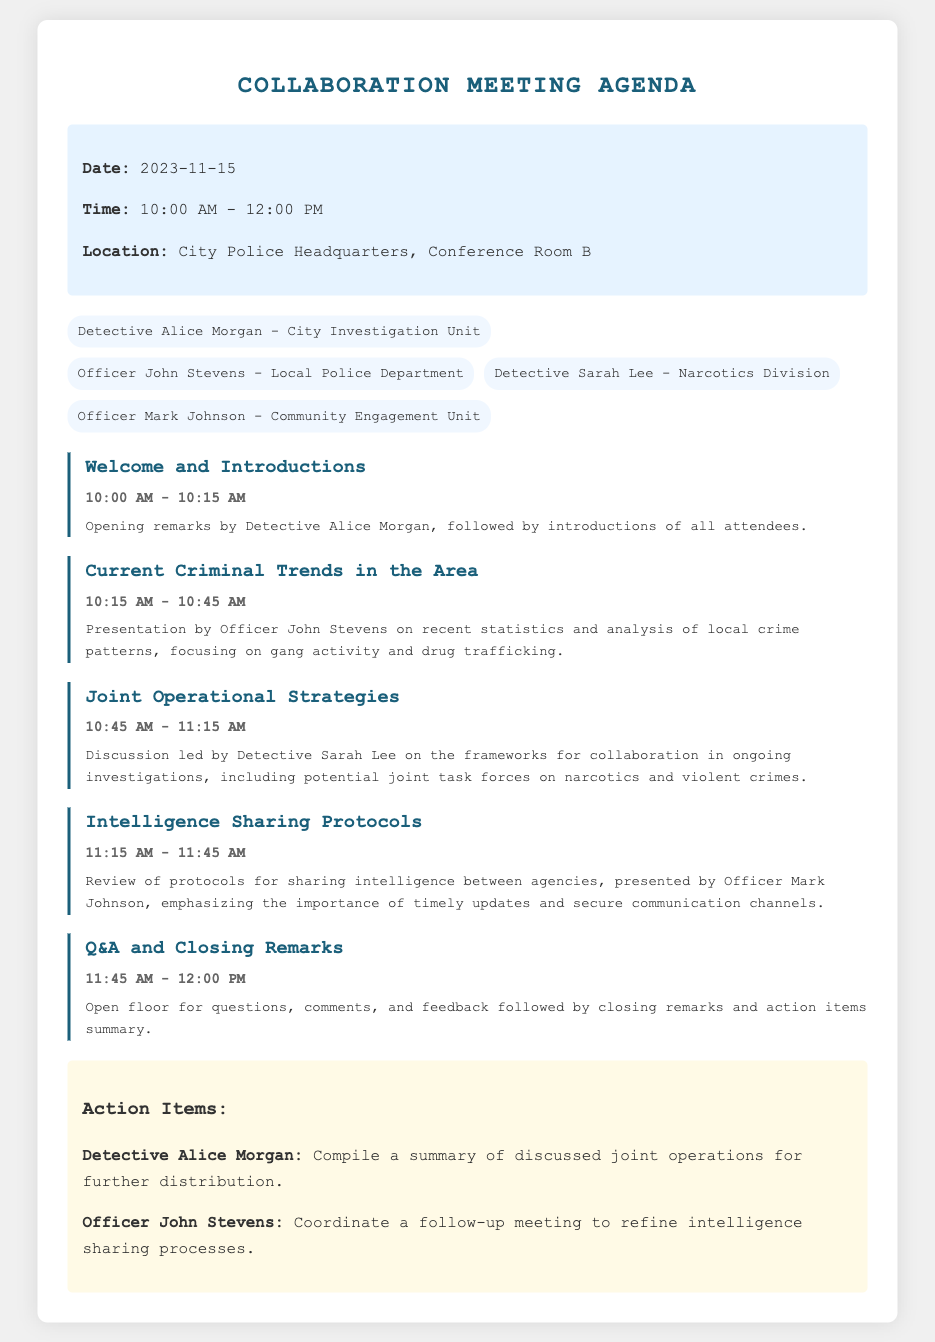What is the date of the meeting? The date is specified in the meeting information section of the document.
Answer: 2023-11-15 Who is opening the meeting? The agenda indicates who will give the opening remarks during the welcome and introductions segment.
Answer: Detective Alice Morgan What topic is being presented by Officer John Stevens? The agenda item specifies the focus of Officer John Stevens' presentation.
Answer: Current Criminal Trends in the Area How long is the discussion on Joint Operational Strategies scheduled for? The agenda lists the duration allocated for the discussion on this particular topic.
Answer: 30 minutes Which division is Detective Sarah Lee part of? The attendees section identifies Detective Sarah Lee's division.
Answer: Narcotics Division What is one of the action items for Detective Alice Morgan? The action items section outlines responsibilities assigned to specific attendees.
Answer: Compile a summary of discussed joint operations for further distribution At what time does the Q&A session start? The agenda indicates when the Q&A and closing remarks segment will begin.
Answer: 11:45 AM What is emphasized in Officer Mark Johnson's presentation? The agenda details the focus of the presentation on intelligence sharing protocols.
Answer: The importance of timely updates and secure communication channels What is the main location of the meeting? The meeting information section states the location where the meeting will take place.
Answer: City Police Headquarters, Conference Room B 